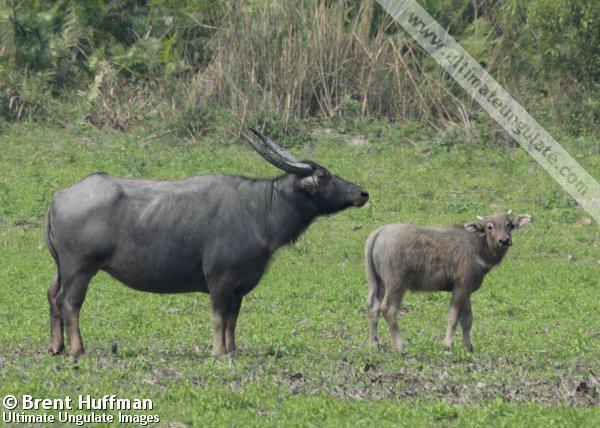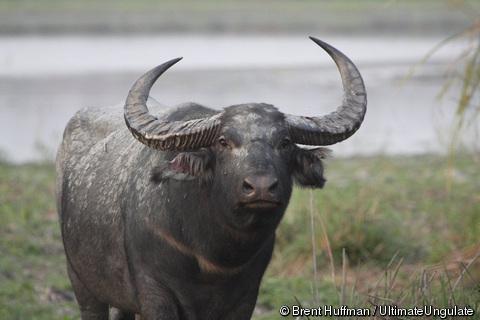The first image is the image on the left, the second image is the image on the right. Considering the images on both sides, is "There are exactly two animals in the image on the left." valid? Answer yes or no. Yes. The first image is the image on the left, the second image is the image on the right. Evaluate the accuracy of this statement regarding the images: "Two cows are in the picture on the left.". Is it true? Answer yes or no. Yes. 